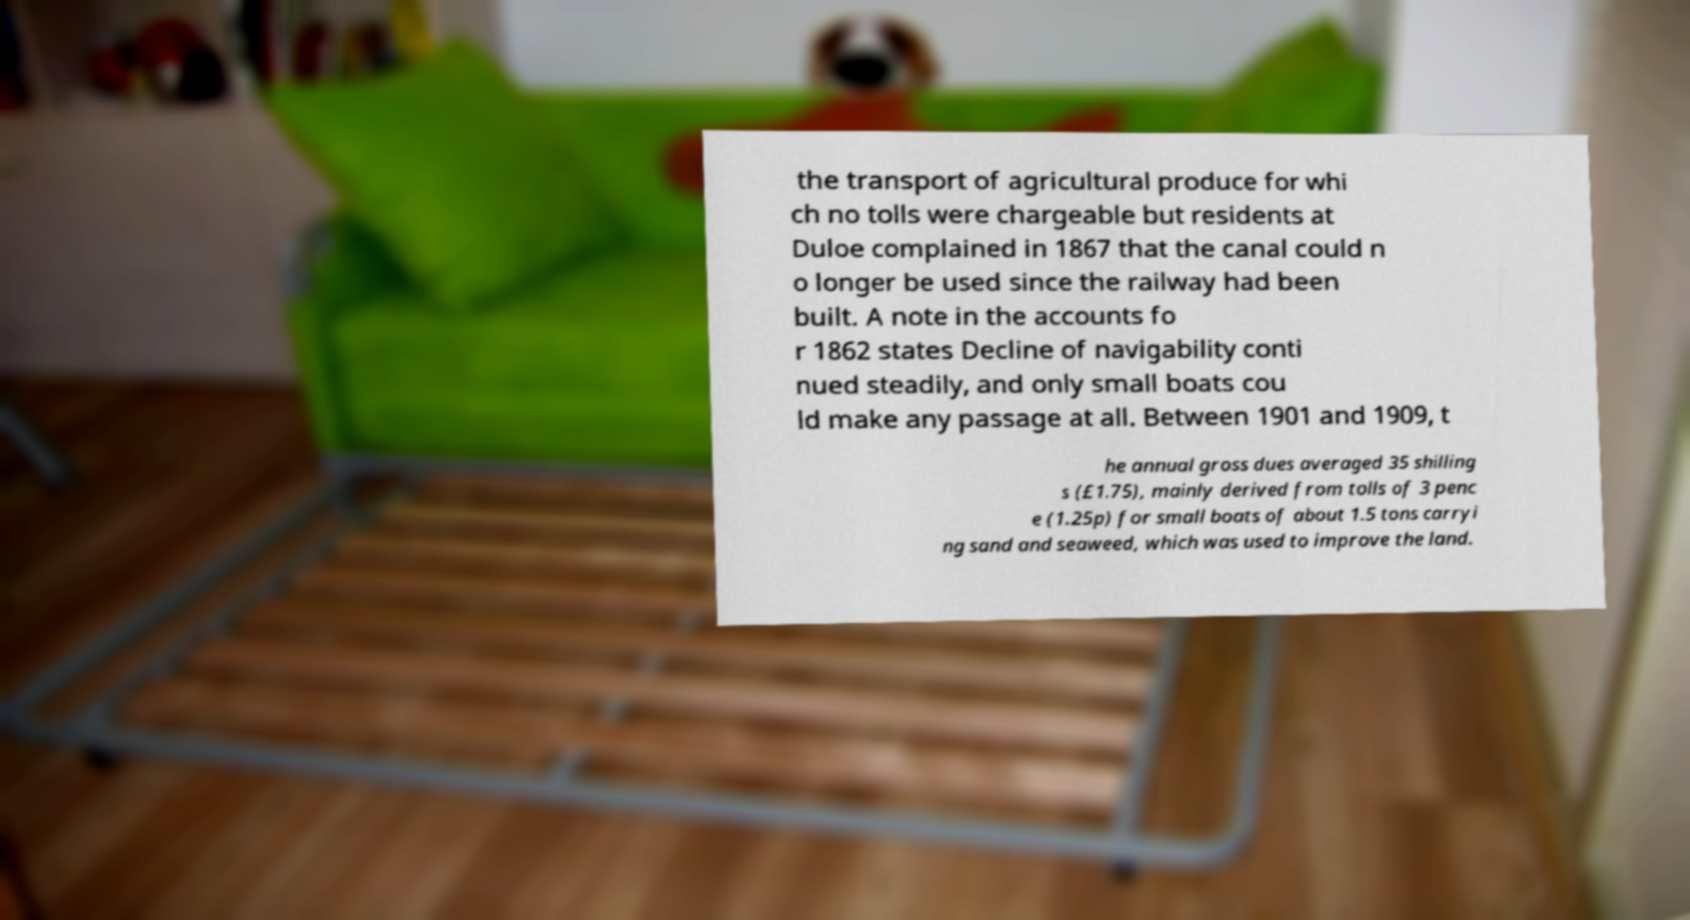Please identify and transcribe the text found in this image. the transport of agricultural produce for whi ch no tolls were chargeable but residents at Duloe complained in 1867 that the canal could n o longer be used since the railway had been built. A note in the accounts fo r 1862 states Decline of navigability conti nued steadily, and only small boats cou ld make any passage at all. Between 1901 and 1909, t he annual gross dues averaged 35 shilling s (£1.75), mainly derived from tolls of 3 penc e (1.25p) for small boats of about 1.5 tons carryi ng sand and seaweed, which was used to improve the land. 